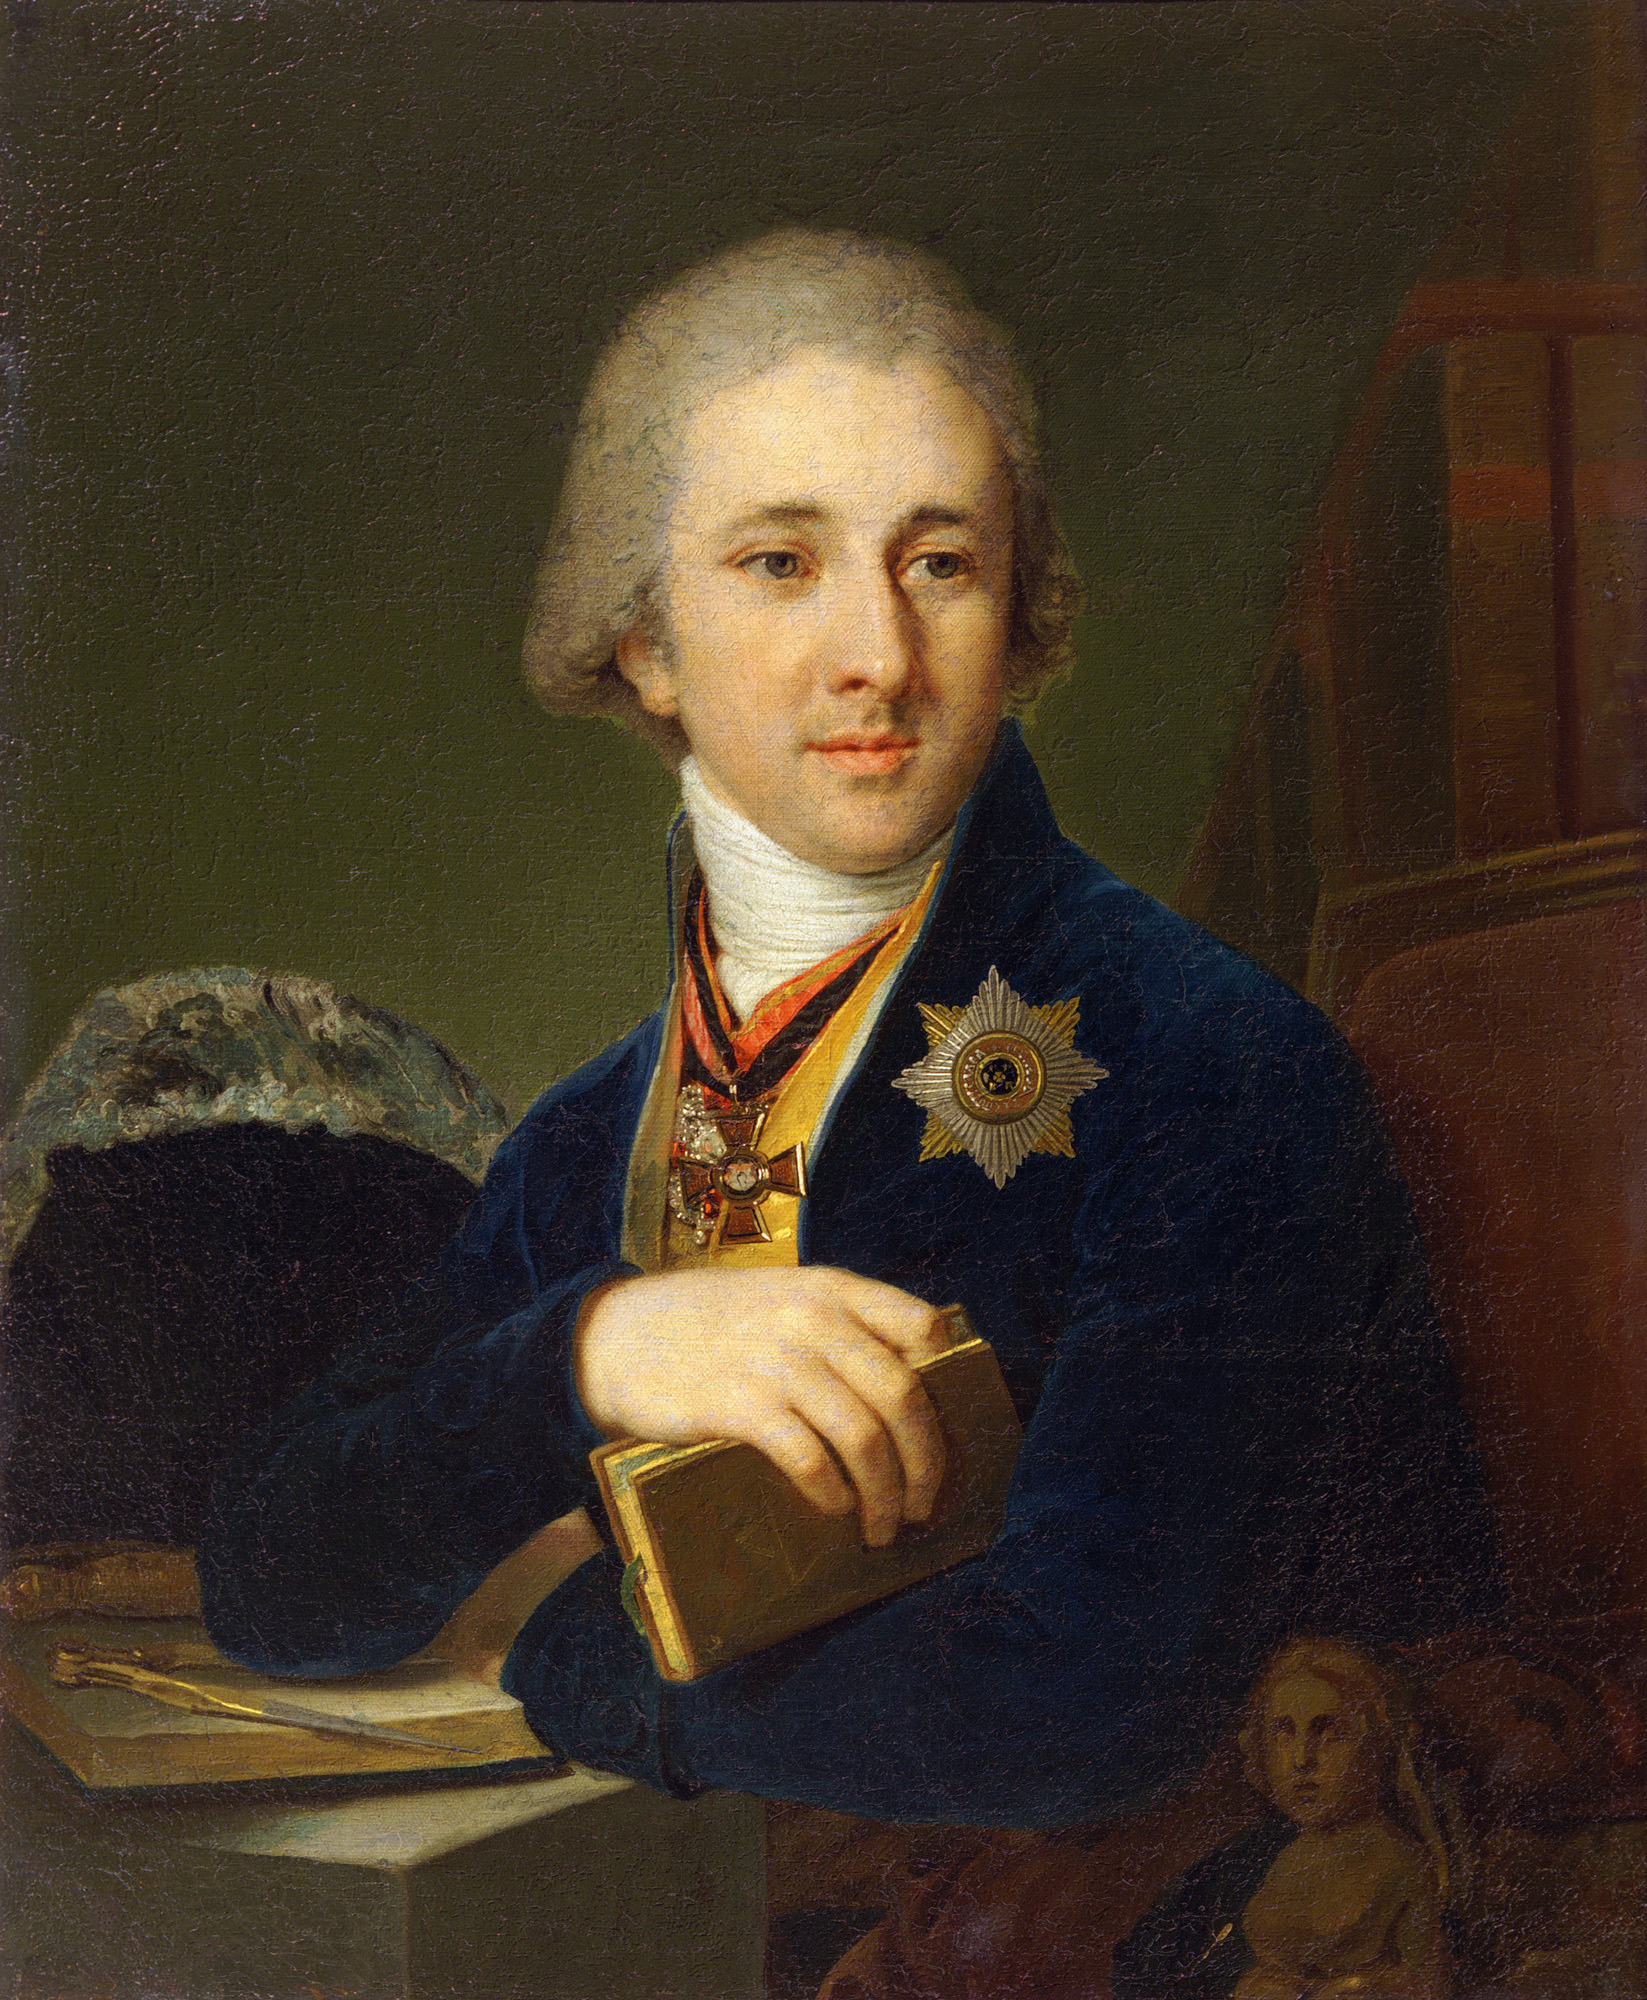What might be some potential historical events or contexts surrounding this portrait? This portrait could be situated in a period of significant cultural and intellectual growth, such as the Enlightenment. The man's attire, the book, and the medals suggest that he could be a figure of importance, possibly part of the intellectual elite or nobility. The Enlightenment was characterized by significant advancements in science, philosophy, and the arts, and figures from this period often embodied these pursuits. How did the Enlightenment period influence portraiture and the arts? The Enlightenment period profoundly influenced portraiture and the arts by emphasizing reason, individualism, and scientific inquiry. Artists began to focus on realism, capturing the true likeness and character of their subjects. Portraits from this era often depicted intellectuals, scientists, and thinkers, highlighting their achievements and contributions. The emphasis on education and knowledge also led to a greater inclusion of symbolic elements, such as books and scientific instruments, in artwork to represent the intellect and virtues of the subjects. If this man could come alive and speak today, what do you think his thoughts would be on modern technology? If this man could come alive and experience modern technology, he would likely be astonished by the advancements we've made. Initially, he might struggle to comprehend the rapid pace of development and the sheer scale of connectivity through the internet and digital communication. As an intellectual, he might be particularly fascinated by how technology has revolutionized access to knowledge, with information readily available at our fingertips. He may also reflect on the implications for society, pondering both the potential benefits in furthering education and research and the challenges in maintaining ethical standards and human connection in an increasingly digital world. 